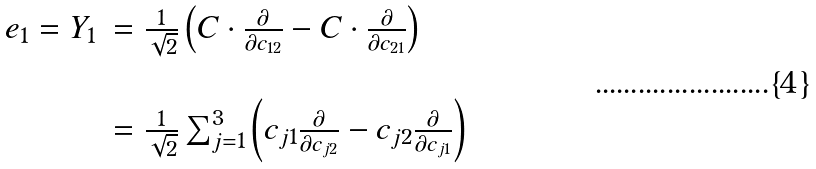Convert formula to latex. <formula><loc_0><loc_0><loc_500><loc_500>\begin{array} { r l } e _ { 1 } = Y _ { 1 } & = \frac { 1 } { \sqrt { 2 } } \left ( C \cdot \frac { \partial } { \partial c _ { 1 2 } } - C \cdot \frac { \partial } { \partial c _ { 2 1 } } \right ) \\ \\ & = \frac { 1 } { \sqrt { 2 } } \sum _ { j = 1 } ^ { 3 } \left ( c _ { j 1 } \frac { \partial } { \partial c _ { j 2 } } - c _ { j 2 } \frac { \partial } { \partial c _ { j 1 } } \right ) \end{array}</formula> 